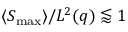<formula> <loc_0><loc_0><loc_500><loc_500>\langle S _ { \max } \rangle / L ^ { 2 } ( q ) \lessapprox 1</formula> 